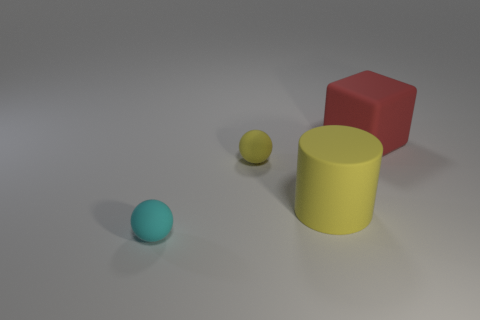There is a rubber object that is the same size as the yellow cylinder; what color is it?
Make the answer very short. Red. How many blocks are yellow rubber objects or large yellow objects?
Your answer should be very brief. 0. How many yellow rubber cylinders are there?
Provide a succinct answer. 1. Do the large yellow rubber object and the matte object that is to the left of the tiny yellow matte sphere have the same shape?
Make the answer very short. No. There is a object that is the same color as the cylinder; what size is it?
Provide a short and direct response. Small. What number of objects are yellow cylinders or big red rubber cubes?
Give a very brief answer. 2. There is a large thing in front of the big object that is on the right side of the yellow rubber cylinder; what is its shape?
Provide a succinct answer. Cylinder. Is the shape of the tiny thing in front of the yellow matte sphere the same as  the tiny yellow thing?
Make the answer very short. Yes. What is the size of the cylinder that is made of the same material as the cyan object?
Ensure brevity in your answer.  Large. What number of objects are either small things behind the cylinder or big objects that are left of the red thing?
Provide a succinct answer. 2. 